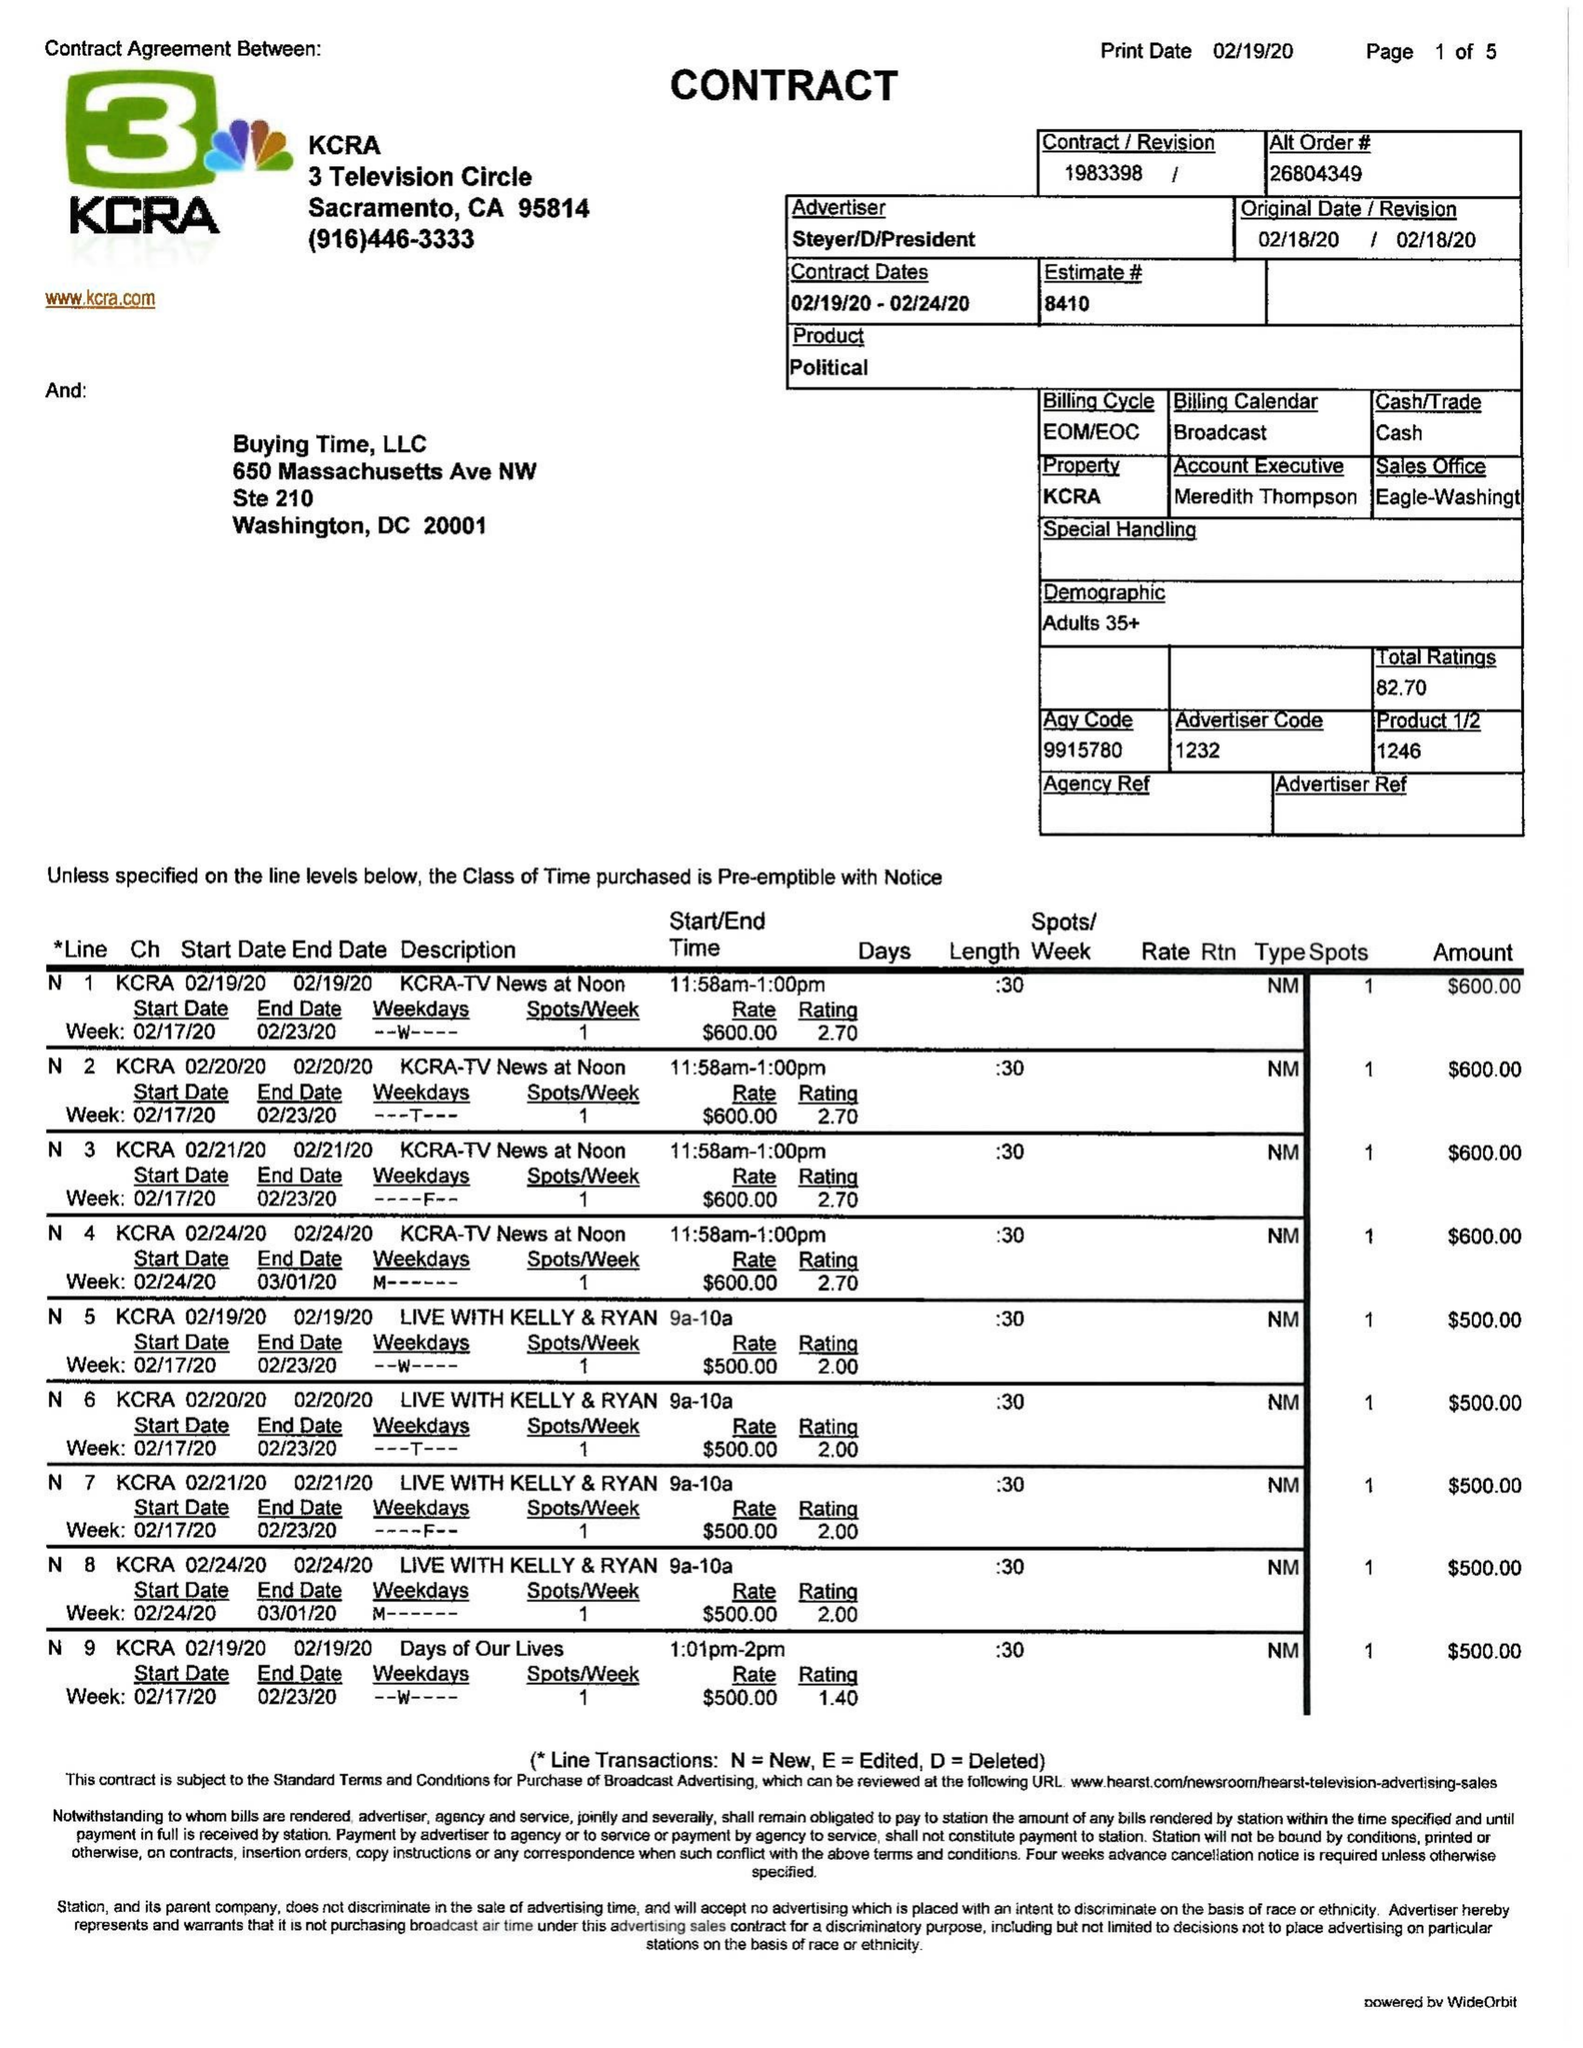What is the value for the flight_from?
Answer the question using a single word or phrase. 02/19/20 